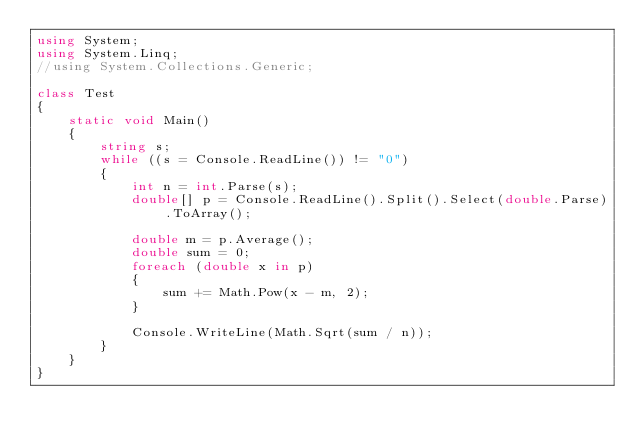<code> <loc_0><loc_0><loc_500><loc_500><_C#_>using System;
using System.Linq;
//using System.Collections.Generic;

class Test
{
    static void Main()
    {
        string s;
        while ((s = Console.ReadLine()) != "0")
        {
            int n = int.Parse(s);
            double[] p = Console.ReadLine().Split().Select(double.Parse).ToArray();

            double m = p.Average();
            double sum = 0;
            foreach (double x in p)
            {
                sum += Math.Pow(x - m, 2);
            }

            Console.WriteLine(Math.Sqrt(sum / n));
        }
    }
}
</code> 